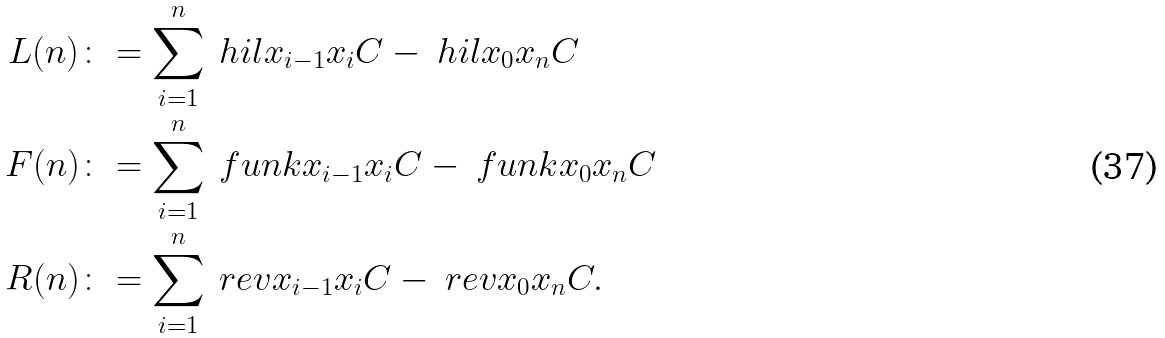Convert formula to latex. <formula><loc_0><loc_0><loc_500><loc_500>L ( n ) & \colon = \sum _ { i = 1 } ^ { n } \ h i l { x _ { i - 1 } } { x _ { i } } { C } - \ h i l { x _ { 0 } } { x _ { n } } { C } \\ F ( n ) & \colon = \sum _ { i = 1 } ^ { n } \ f u n k { x _ { i - 1 } } { x _ { i } } { C } - \ f u n k { x _ { 0 } } { x _ { n } } { C } \\ R ( n ) & \colon = \sum _ { i = 1 } ^ { n } \ r e v { x _ { i - 1 } } { x _ { i } } { C } - \ r e v { x _ { 0 } } { x _ { n } } { C } .</formula> 